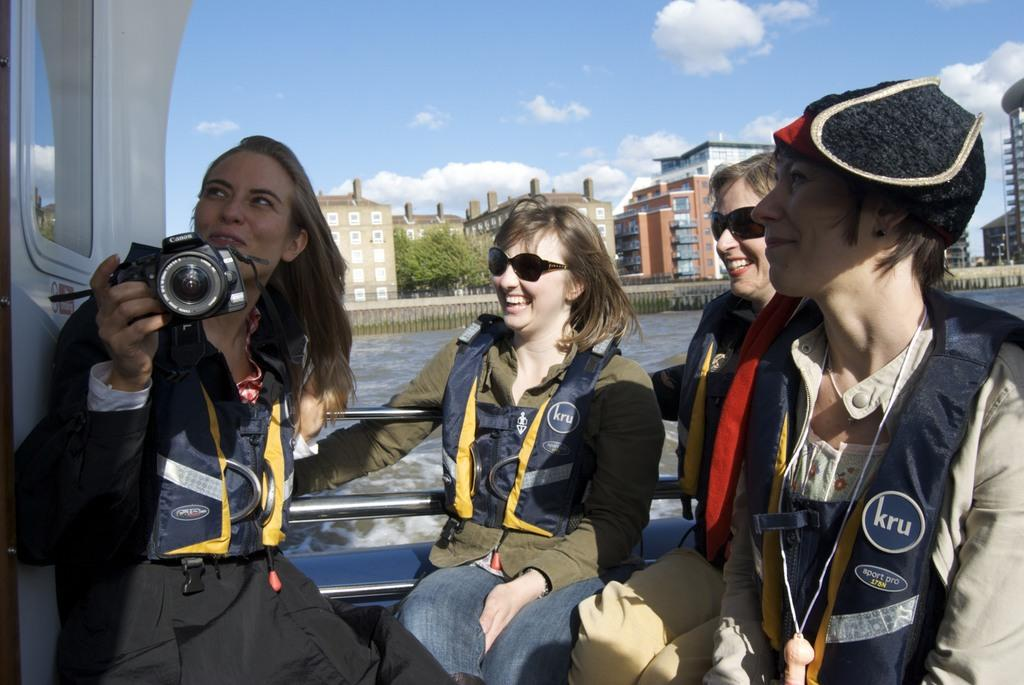What is the main subject of the image? The main subject of the image is a ship. What are the women in the ship doing? The provided facts do not specify what the women are doing in the ship. Can you describe the woman holding a camera on the left side of the ship? Yes, a woman is holding a camera on the left side of the ship. What can be seen in the background of the image? In the background of the image, there are buildings, trees, water, and the sky. What is the condition of the sky in the image? The sky is visible in the background of the image, and clouds are present. What type of star can be seen in the image? There is no star visible in the image; it features a ship with women and a woman holding a camera, as well as a background with buildings, trees, water, and the sky. How many fish are visible in the image? There are no fish present in the image. 